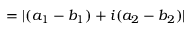Convert formula to latex. <formula><loc_0><loc_0><loc_500><loc_500>= | ( a _ { 1 } - b _ { 1 } ) + i ( a _ { 2 } - b _ { 2 } ) |</formula> 